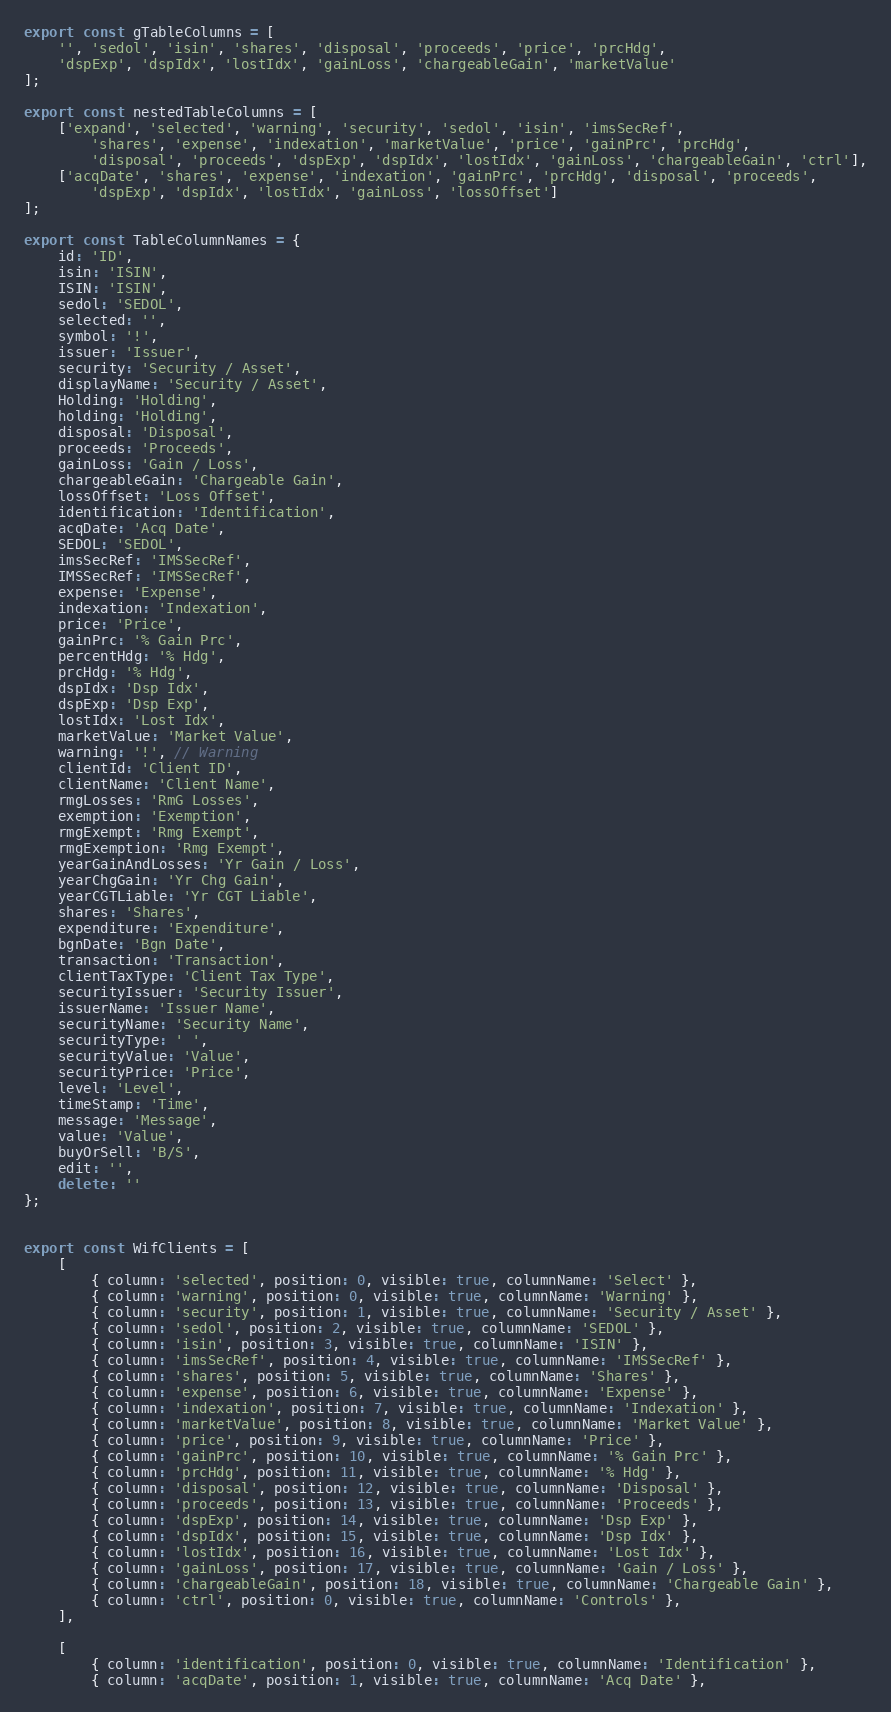Convert code to text. <code><loc_0><loc_0><loc_500><loc_500><_TypeScript_>
export const gTableColumns = [
    '', 'sedol', 'isin', 'shares', 'disposal', 'proceeds', 'price', 'prcHdg',
    'dspExp', 'dspIdx', 'lostIdx', 'gainLoss', 'chargeableGain', 'marketValue'
];

export const nestedTableColumns = [
    ['expand', 'selected', 'warning', 'security', 'sedol', 'isin', 'imsSecRef',
        'shares', 'expense', 'indexation', 'marketValue', 'price', 'gainPrc', 'prcHdg',
        'disposal', 'proceeds', 'dspExp', 'dspIdx', 'lostIdx', 'gainLoss', 'chargeableGain', 'ctrl'],
    ['acqDate', 'shares', 'expense', 'indexation', 'gainPrc', 'prcHdg', 'disposal', 'proceeds',
        'dspExp', 'dspIdx', 'lostIdx', 'gainLoss', 'lossOffset']
];

export const TableColumnNames = {
    id: 'ID',
    isin: 'ISIN',
    ISIN: 'ISIN',
    sedol: 'SEDOL',
    selected: '',
    symbol: '!',
    issuer: 'Issuer',
    security: 'Security / Asset',
    displayName: 'Security / Asset',
    Holding: 'Holding',
    holding: 'Holding',
    disposal: 'Disposal',
    proceeds: 'Proceeds',
    gainLoss: 'Gain / Loss',
    chargeableGain: 'Chargeable Gain',
    lossOffset: 'Loss Offset',
    identification: 'Identification',
    acqDate: 'Acq Date',
    SEDOL: 'SEDOL',
    imsSecRef: 'IMSSecRef',
    IMSSecRef: 'IMSSecRef',
    expense: 'Expense',
    indexation: 'Indexation',
    price: 'Price',
    gainPrc: '% Gain Prc',
    percentHdg: '% Hdg',
    prcHdg: '% Hdg',
    dspIdx: 'Dsp Idx',
    dspExp: 'Dsp Exp',
    lostIdx: 'Lost Idx',
    marketValue: 'Market Value',
    warning: '!', // Warning
    clientId: 'Client ID',
    clientName: 'Client Name',
    rmgLosses: 'RmG Losses',
    exemption: 'Exemption',
    rmgExempt: 'Rmg Exempt',
    rmgExemption: 'Rmg Exempt',
    yearGainAndLosses: 'Yr Gain / Loss',
    yearChgGain: 'Yr Chg Gain',
    yearCGTLiable: 'Yr CGT Liable',
    shares: 'Shares',
    expenditure: 'Expenditure',
    bgnDate: 'Bgn Date',
    transaction: 'Transaction',
    clientTaxType: 'Client Tax Type',
    securityIssuer: 'Security Issuer',
    issuerName: 'Issuer Name',
    securityName: 'Security Name',
    securityType: ' ',
    securityValue: 'Value',
    securityPrice: 'Price',
    level: 'Level',
    timeStamp: 'Time',
    message: 'Message',
    value: 'Value',
    buyOrSell: 'B/S',
    edit: '',
    delete: ''
};


export const WifClients = [
    [
        { column: 'selected', position: 0, visible: true, columnName: 'Select' },
        { column: 'warning', position: 0, visible: true, columnName: 'Warning' },
        { column: 'security', position: 1, visible: true, columnName: 'Security / Asset' },
        { column: 'sedol', position: 2, visible: true, columnName: 'SEDOL' },
        { column: 'isin', position: 3, visible: true, columnName: 'ISIN' },
        { column: 'imsSecRef', position: 4, visible: true, columnName: 'IMSSecRef' },
        { column: 'shares', position: 5, visible: true, columnName: 'Shares' },
        { column: 'expense', position: 6, visible: true, columnName: 'Expense' },
        { column: 'indexation', position: 7, visible: true, columnName: 'Indexation' },
        { column: 'marketValue', position: 8, visible: true, columnName: 'Market Value' },
        { column: 'price', position: 9, visible: true, columnName: 'Price' },
        { column: 'gainPrc', position: 10, visible: true, columnName: '% Gain Prc' },
        { column: 'prcHdg', position: 11, visible: true, columnName: '% Hdg' },
        { column: 'disposal', position: 12, visible: true, columnName: 'Disposal' },
        { column: 'proceeds', position: 13, visible: true, columnName: 'Proceeds' },
        { column: 'dspExp', position: 14, visible: true, columnName: 'Dsp Exp' },
        { column: 'dspIdx', position: 15, visible: true, columnName: 'Dsp Idx' },
        { column: 'lostIdx', position: 16, visible: true, columnName: 'Lost Idx' },
        { column: 'gainLoss', position: 17, visible: true, columnName: 'Gain / Loss' },
        { column: 'chargeableGain', position: 18, visible: true, columnName: 'Chargeable Gain' },
        { column: 'ctrl', position: 0, visible: true, columnName: 'Controls' },
    ],

    [
        { column: 'identification', position: 0, visible: true, columnName: 'Identification' },
        { column: 'acqDate', position: 1, visible: true, columnName: 'Acq Date' },</code> 